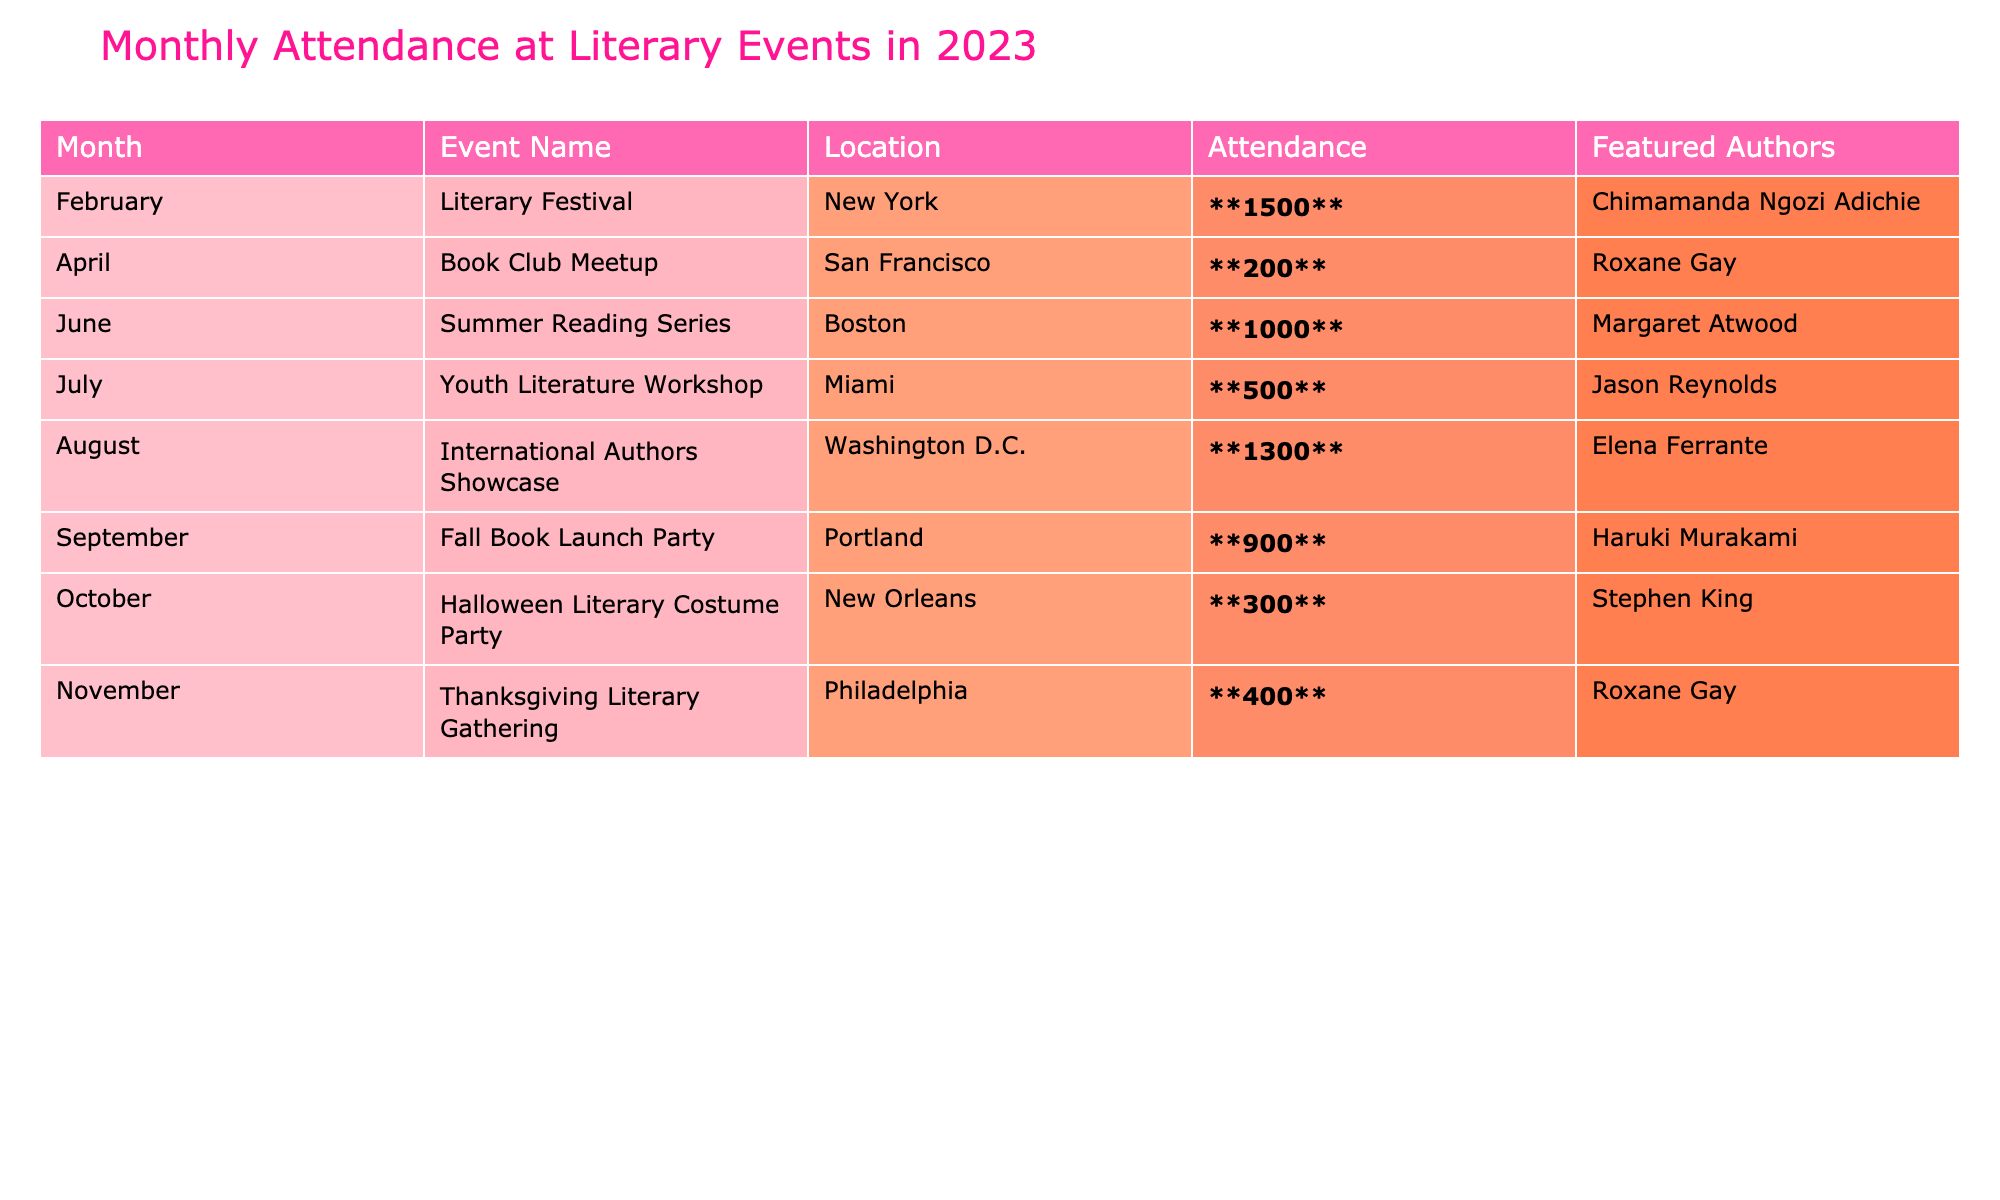What was the attendance at the International Authors Showcase? The table indicates that the attendance for the International Authors Showcase in August was **1300**.
Answer: 1300 How many events had an attendance of over 1000? From the table, there are two events with attendance over 1000: the Literary Festival (1500) and the International Authors Showcase (1300).
Answer: 2 What is the total attendance across all events listed? Summing up the attendance values: 1500 + 200 + 1000 + 500 + 1300 + 900 + 300 + 400 = 5100.
Answer: 5100 Was Roxane Gay featured as an author in events that had more than 500 attendees? Roxane Gay was featured in the Book Club Meetup (200) and the Thanksgiving Literary Gathering (400), both of which had less than 500 attendees, so the answer is no.
Answer: No Which month had the lowest attendance and what was the value? The month with the lowest attendance is April with **200** attendees at the Book Club Meetup.
Answer: April, 200 Calculate the average attendance of the events held in the second half of the year (July to December). The events from July to December are: Youth Literature Workshop (500), International Authors Showcase (1300), Fall Book Launch Party (900), Halloween Literary Costume Party (300), Thanksgiving Literary Gathering (400). The total attendance is 500 + 1300 + 900 + 300 + 400 = 3400. There are 5 events, so the average is 3400/5 = 680.
Answer: 680 Did any event's attendance reach exactly 300? Checking the table, the Halloween Literary Costume Party in October had an attendance of **300**, so the answer is yes.
Answer: Yes Which event had the highest attendance and what were its featured authors? The event with the highest attendance was the Literary Festival in February with **1500** attendees, featuring Chimamanda Ngozi Adichie.
Answer: Literary Festival, Chimamanda Ngozi Adichie If you compare September's Fall Book Launch Party to June's Summer Reading Series, which had higher attendance? The Fall Book Launch Party had **900** attendees while the Summer Reading Series had **1000** attendees. Therefore, June's event had higher attendance.
Answer: June's event How many events had Roxane Gay as a featured author? Roxane Gay was featured in two events: the Book Club Meetup and the Thanksgiving Literary Gathering.
Answer: 2 